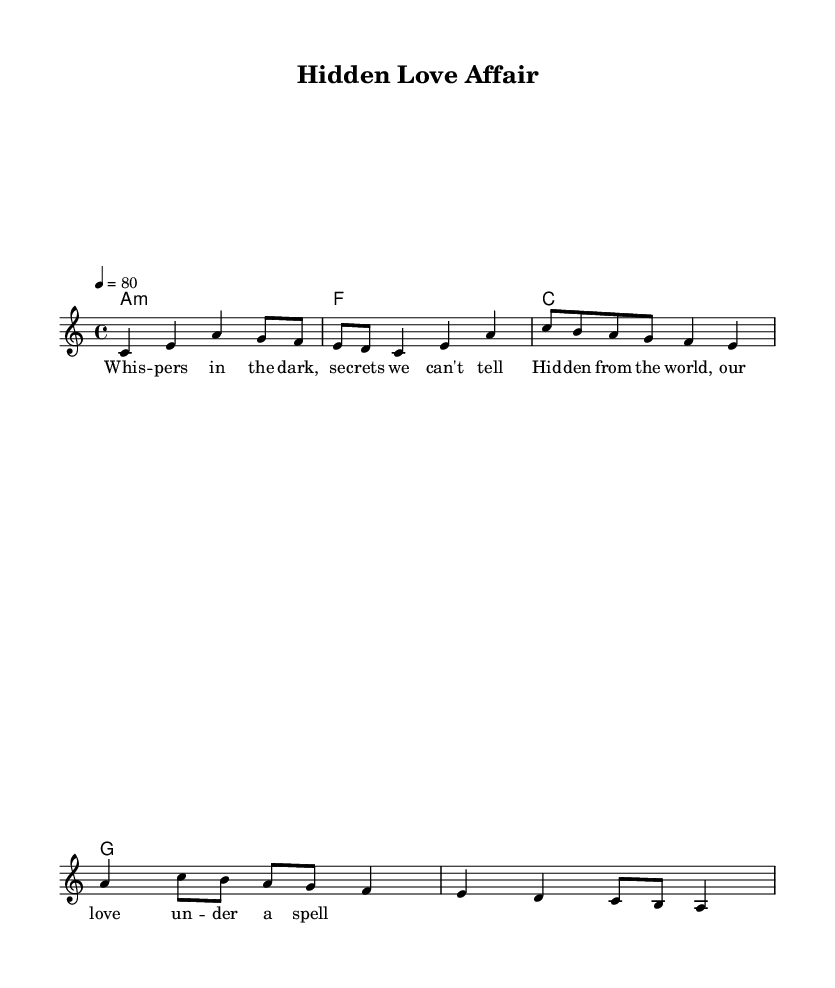What is the key signature of this music? The key signature is indicated by the notes presented in the staff. Since there are no sharps or flats, this implies a key of A minor, as A minor is the relative minor of C major, which also has no sharps or flats.
Answer: A minor What is the time signature of this music? The time signature is explicitly stated at the beginning of the score as 4/4, indicating that there are four beats per measure, and the quarter note gets one beat.
Answer: 4/4 What is the tempo marking for this piece? The tempo marking indicates the speed of the piece and is marked as "4 = 80," meaning that there are 80 beats per minute, where each quarter note is played at the speed of one beat per click.
Answer: 80 How many measures are in the melody? By counting the distinct groups of notes in the melody line, there are four measures indicated by the grouping of the notes and the respective musical bar lines.
Answer: 4 What type of harmonic structure appears in this music? The harmonic structure is a standard chord progression appearing at the start of each four measures (A minor, F major, C major, G major), showing a classic I-IV-V structure typical of R&B music.
Answer: I-IV-V What theme does the lyric suggest? The lyrics suggest a theme of hidden love and secrecy, as indicated by phrases like "whispers in the dark" and "hidden from the world," which point to a clandestine relationship often found in R&B narratives.
Answer: Hidden love 